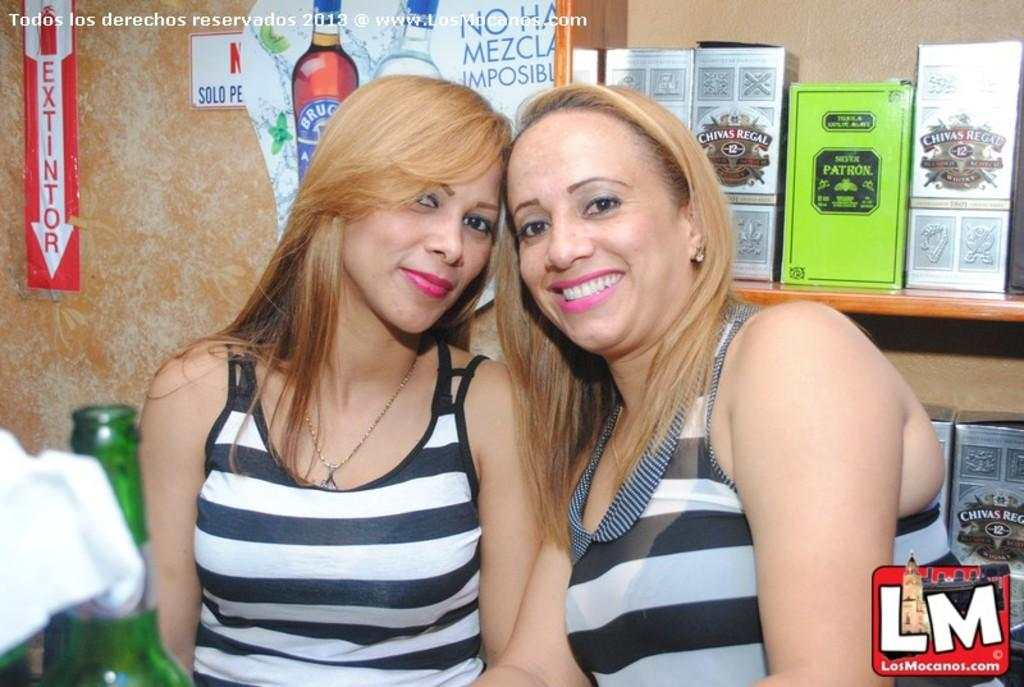How many women are in the image? There are two women in the image. What are the women doing in the image? The women are standing next to each other. What object can be seen in the image besides the women? There is a bottle in the image. What can be seen in the background of the image? There is a wall, a poster, and boxes in the background of the image. How many jellyfish are swimming in the background of the image? There are no jellyfish present in the image; it features two women standing next to each other, a bottle, and objects in the background. What type of knowledge can be gained from the kettle in the image? There is no kettle present in the image, so no knowledge can be gained from it. 